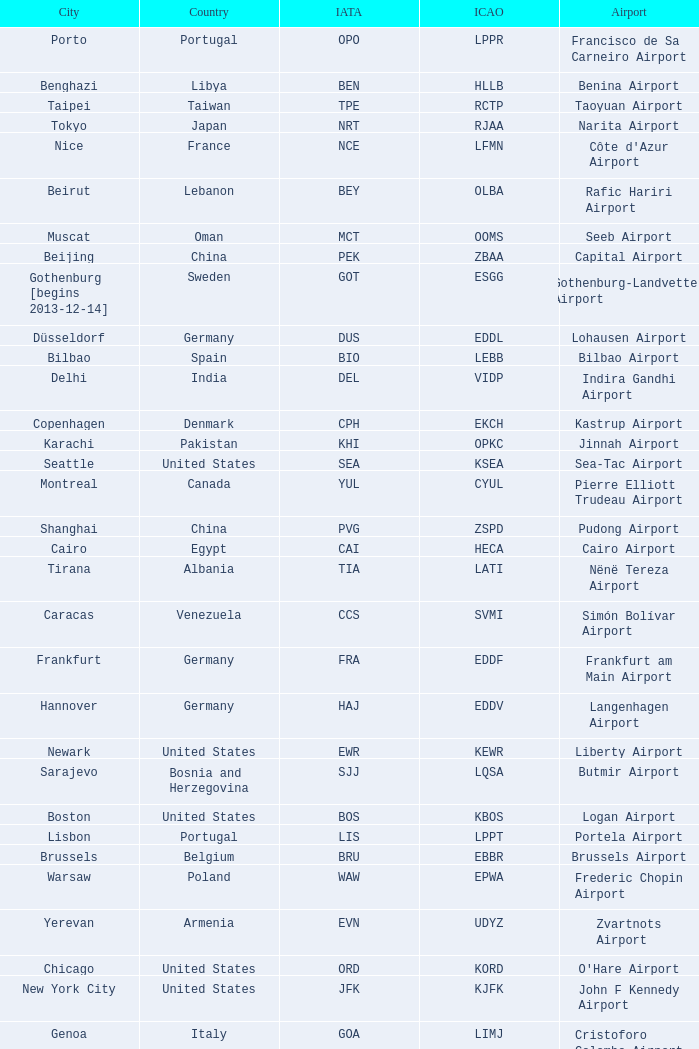What is the ICAO of Lohausen airport? EDDL. 